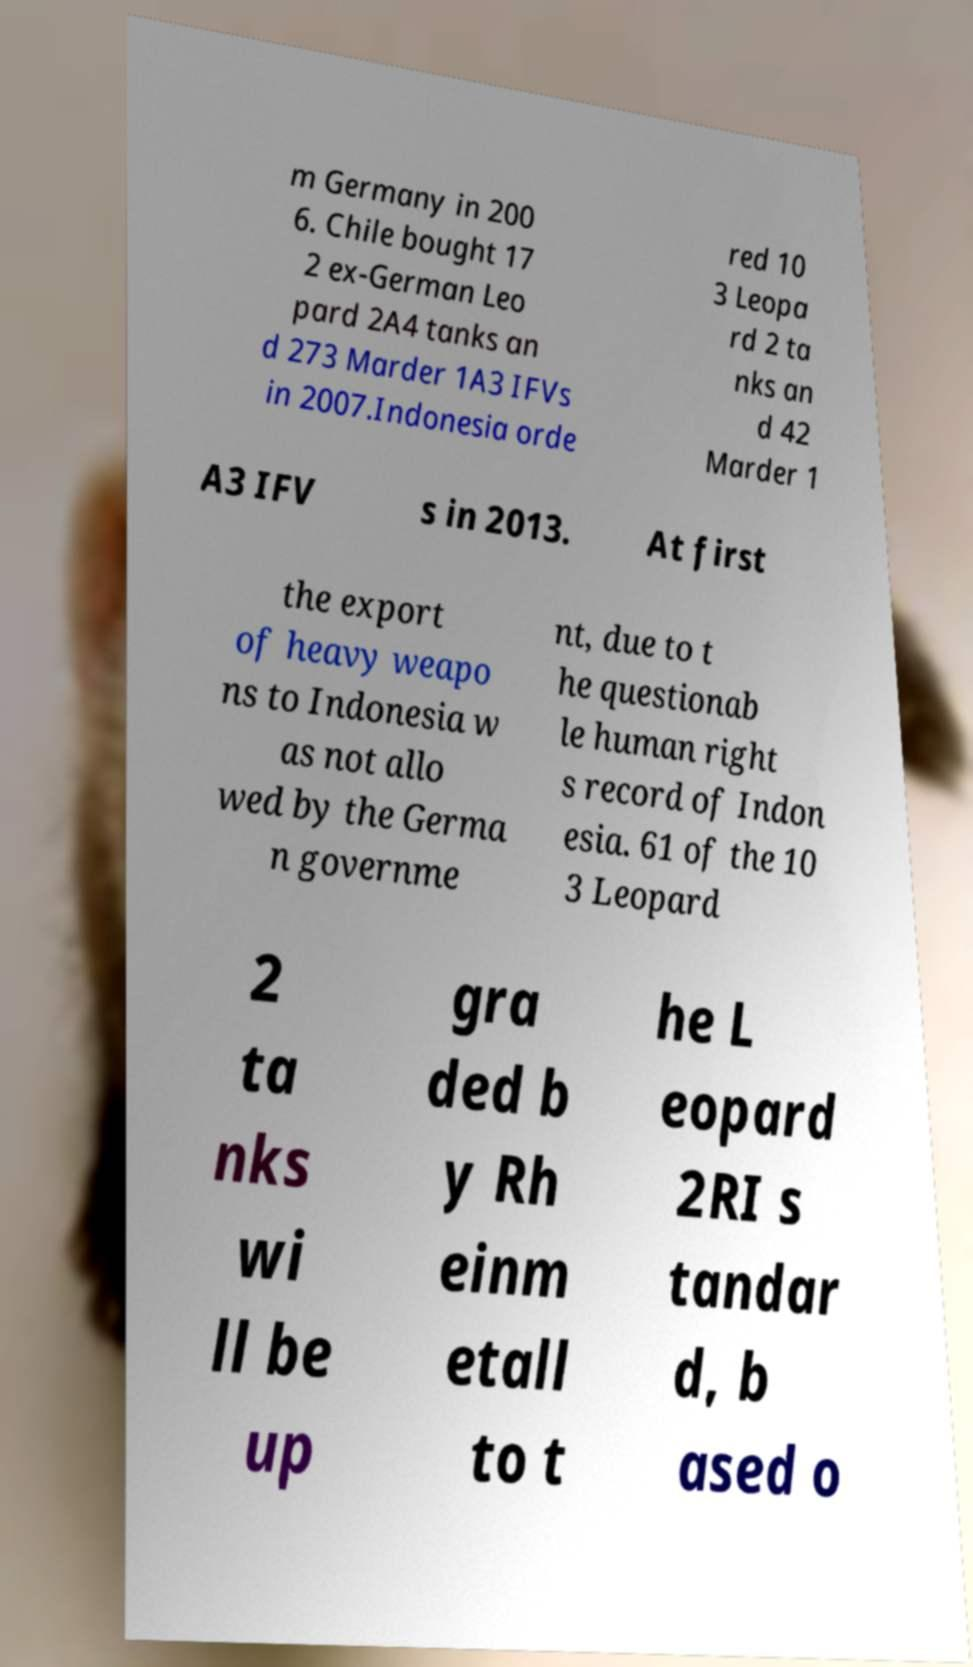What messages or text are displayed in this image? I need them in a readable, typed format. m Germany in 200 6. Chile bought 17 2 ex-German Leo pard 2A4 tanks an d 273 Marder 1A3 IFVs in 2007.Indonesia orde red 10 3 Leopa rd 2 ta nks an d 42 Marder 1 A3 IFV s in 2013. At first the export of heavy weapo ns to Indonesia w as not allo wed by the Germa n governme nt, due to t he questionab le human right s record of Indon esia. 61 of the 10 3 Leopard 2 ta nks wi ll be up gra ded b y Rh einm etall to t he L eopard 2RI s tandar d, b ased o 